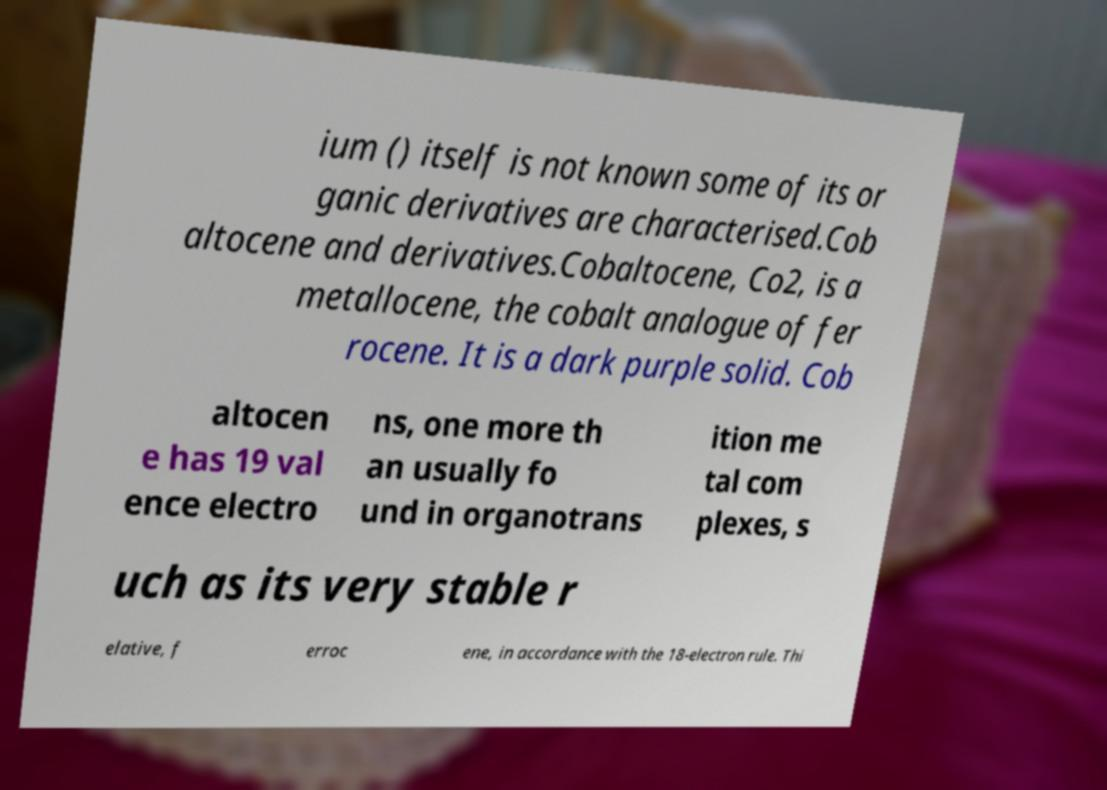Could you assist in decoding the text presented in this image and type it out clearly? ium () itself is not known some of its or ganic derivatives are characterised.Cob altocene and derivatives.Cobaltocene, Co2, is a metallocene, the cobalt analogue of fer rocene. It is a dark purple solid. Cob altocen e has 19 val ence electro ns, one more th an usually fo und in organotrans ition me tal com plexes, s uch as its very stable r elative, f erroc ene, in accordance with the 18-electron rule. Thi 